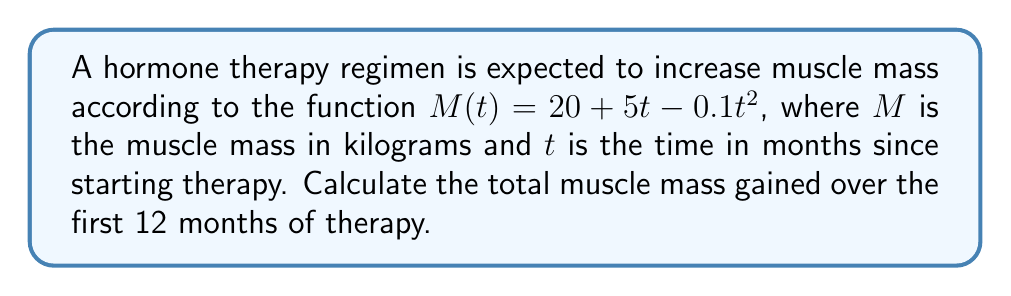Can you answer this question? To solve this problem, we need to use integral calculus to find the area under the curve of the rate of muscle growth.

1) First, we need to find the rate of muscle growth. This is the derivative of $M(t)$:
   $$\frac{dM}{dt} = 5 - 0.2t$$

2) To find the total muscle mass gained, we need to integrate this rate over the given time period:
   $$\text{Total Gain} = \int_0^{12} (5 - 0.2t) dt$$

3) Let's solve this integral:
   $$\begin{align}
   \int_0^{12} (5 - 0.2t) dt &= [5t - 0.1t^2]_0^{12} \\
   &= (5(12) - 0.1(12)^2) - (5(0) - 0.1(0)^2) \\
   &= (60 - 14.4) - 0 \\
   &= 45.6
   \end{align}$$

4) Therefore, the total muscle mass gained over 12 months is 45.6 kg.

5) We can verify this by calculating $M(12) - M(0)$:
   $$\begin{align}
   M(12) - M(0) &= (20 + 5(12) - 0.1(12)^2) - (20 + 5(0) - 0.1(0)^2) \\
   &= (20 + 60 - 14.4) - 20 \\
   &= 65.6 - 20 \\
   &= 45.6 \text{ kg}
   \end{align}$$

This confirms our result from the integral method.
Answer: 45.6 kg 